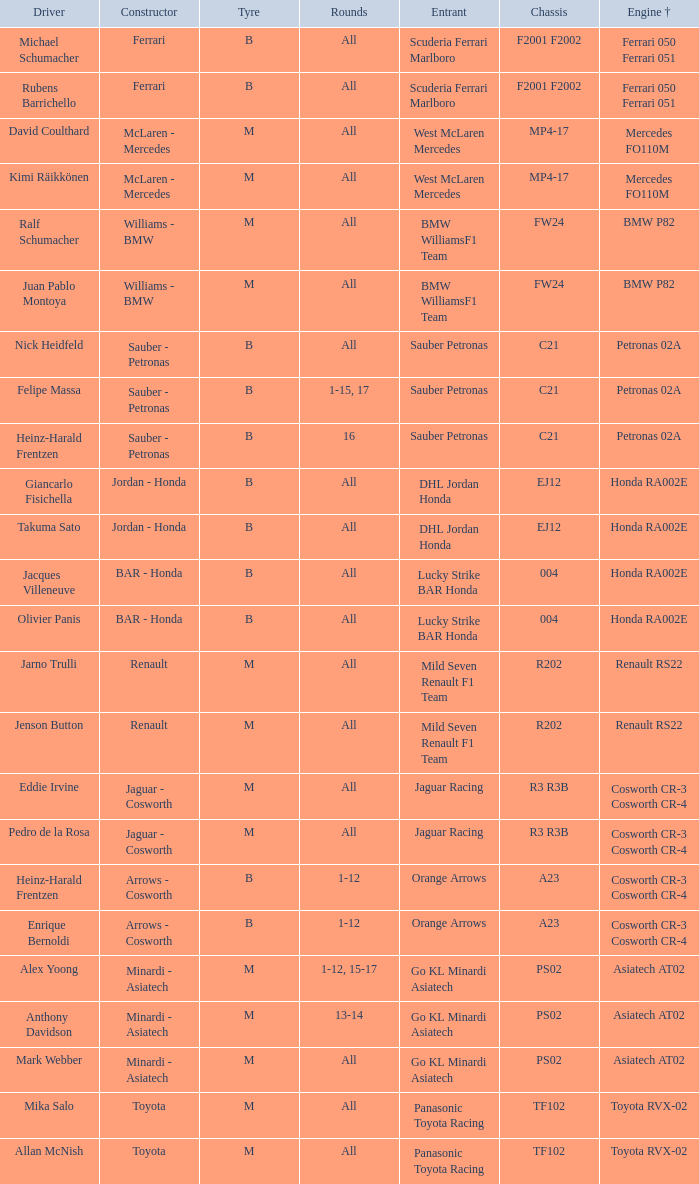Who is the driver when the engine is mercedes fo110m? David Coulthard, Kimi Räikkönen. 